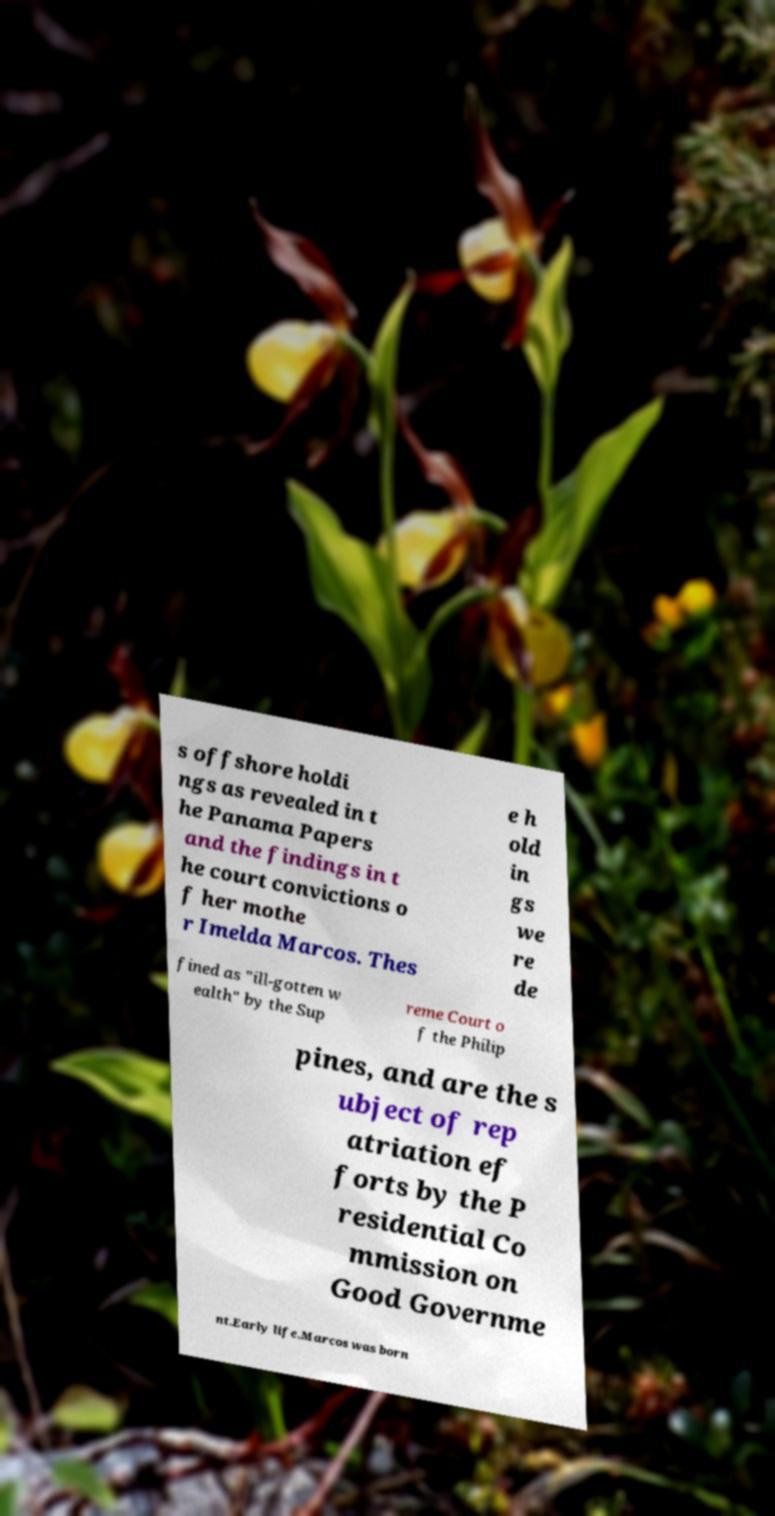Can you accurately transcribe the text from the provided image for me? s offshore holdi ngs as revealed in t he Panama Papers and the findings in t he court convictions o f her mothe r Imelda Marcos. Thes e h old in gs we re de fined as "ill-gotten w ealth" by the Sup reme Court o f the Philip pines, and are the s ubject of rep atriation ef forts by the P residential Co mmission on Good Governme nt.Early life.Marcos was born 